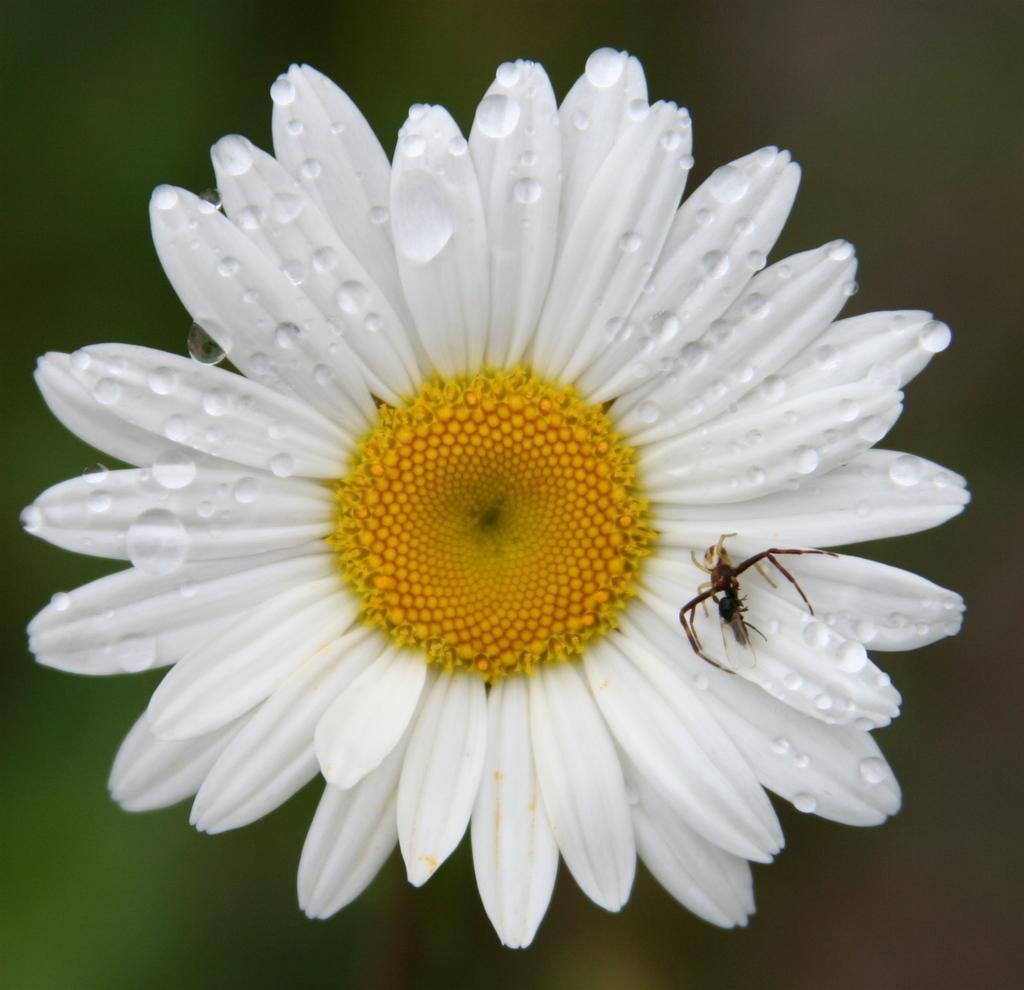Could you give a brief overview of what you see in this image? This image consists of a sunflower in white color. On which there is an ant. 